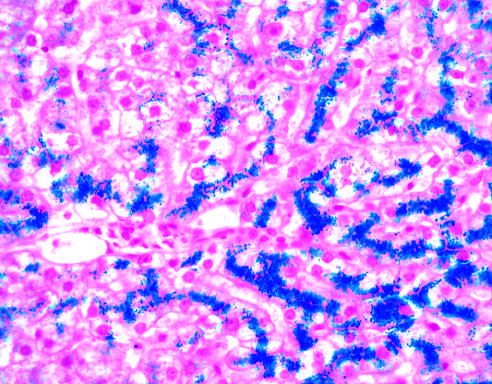does this abnormality appear blue in this prussian blue-stained section?
Answer the question using a single word or phrase. No 